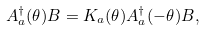Convert formula to latex. <formula><loc_0><loc_0><loc_500><loc_500>A _ { a } ^ { \dagger } ( \theta ) B = K _ { a } ( \theta ) A _ { a } ^ { \dagger } ( - \theta ) B ,</formula> 